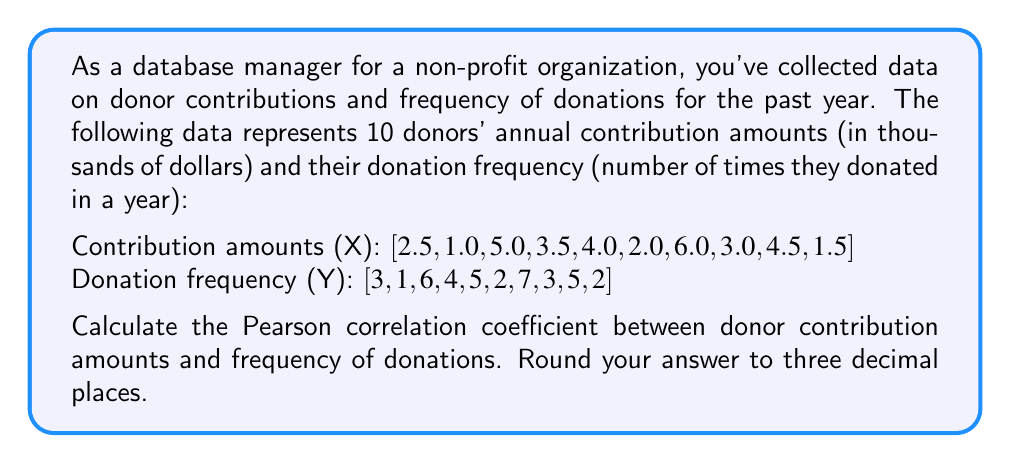Could you help me with this problem? To calculate the Pearson correlation coefficient, we'll follow these steps:

1. Calculate the means of X and Y:
   $$\bar{X} = \frac{\sum_{i=1}^{n} X_i}{n} = \frac{33}{10} = 3.3$$
   $$\bar{Y} = \frac{\sum_{i=1}^{n} Y_i}{n} = \frac{38}{10} = 3.8$$

2. Calculate the deviations from the mean for X and Y:
   $X - \bar{X}$ = [-0.8, -2.3, 1.7, 0.2, 0.7, -1.3, 2.7, -0.3, 1.2, -1.8]
   $Y - \bar{Y}$ = [-0.8, -2.8, 2.2, 0.2, 1.2, -1.8, 3.2, -0.8, 1.2, -1.8]

3. Calculate the products of the deviations:
   $(X - \bar{X})(Y - \bar{Y})$ = [0.64, 6.44, 3.74, 0.04, 0.84, 2.34, 8.64, 0.24, 1.44, 3.24]

4. Calculate the sums needed for the correlation coefficient:
   $$\sum_{i=1}^{n} (X_i - \bar{X})(Y_i - \bar{Y}) = 27.6$$
   $$\sum_{i=1}^{n} (X_i - \bar{X})^2 = 22.21$$
   $$\sum_{i=1}^{n} (Y_i - \bar{Y})^2 = 38.6$$

5. Apply the Pearson correlation coefficient formula:
   $$r = \frac{\sum_{i=1}^{n} (X_i - \bar{X})(Y_i - \bar{Y})}{\sqrt{\sum_{i=1}^{n} (X_i - \bar{X})^2 \sum_{i=1}^{n} (Y_i - \bar{Y})^2}}$$

   $$r = \frac{27.6}{\sqrt{22.21 \times 38.6}} = \frac{27.6}{\sqrt{857.306}} = \frac{27.6}{29.279}$$

6. Round the result to three decimal places:
   $$r \approx 0.943$$
Answer: 0.943 